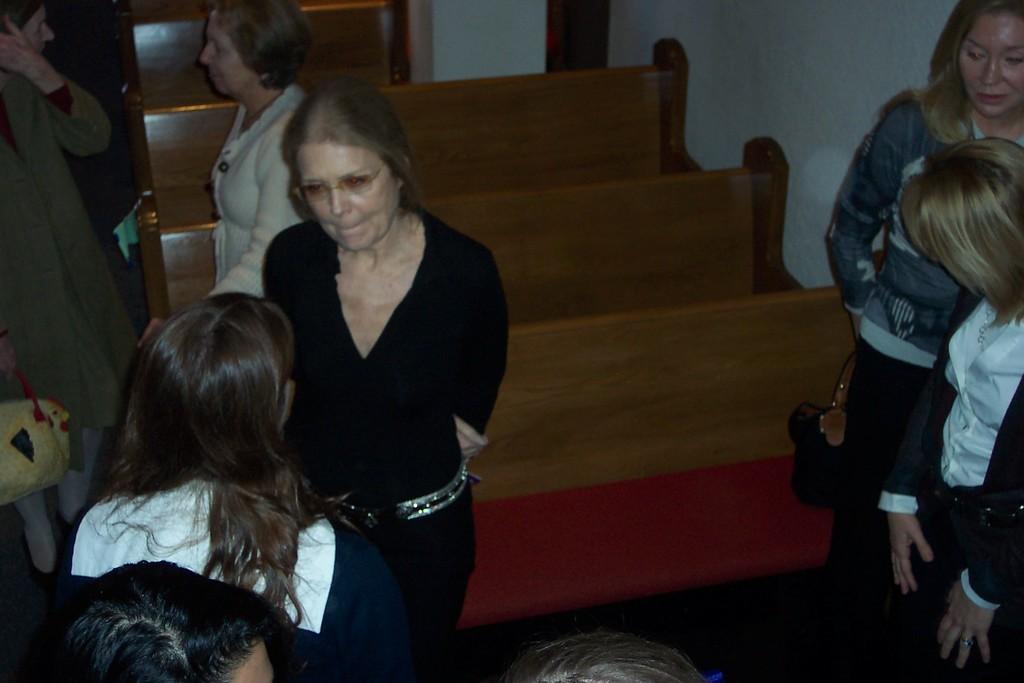In one or two sentences, can you explain what this image depicts? In the image few women are standing. Behind them there are some benches. Top right side of the image there is wall. 